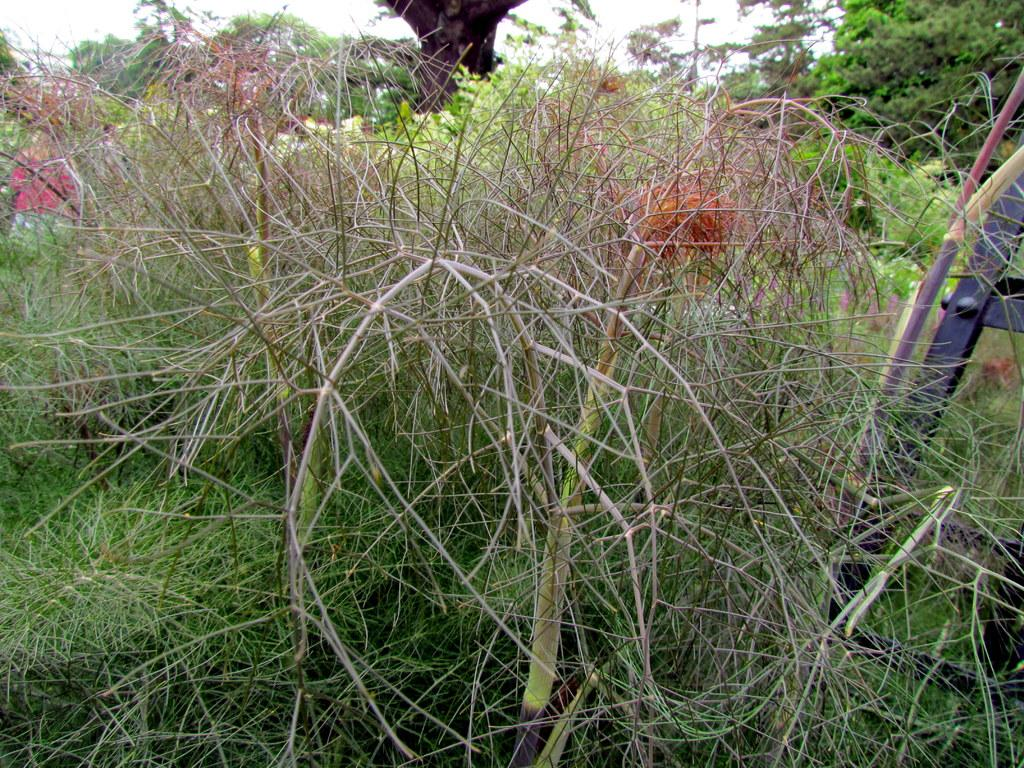What type of living organisms can be seen in the image? Plants and trees are visible in the image. What part of the natural environment is visible in the image? The sky is visible in the image. What type of hammer is being used by the judge in the image? There is no judge or hammer present in the image; it features plants, trees, and the sky. 